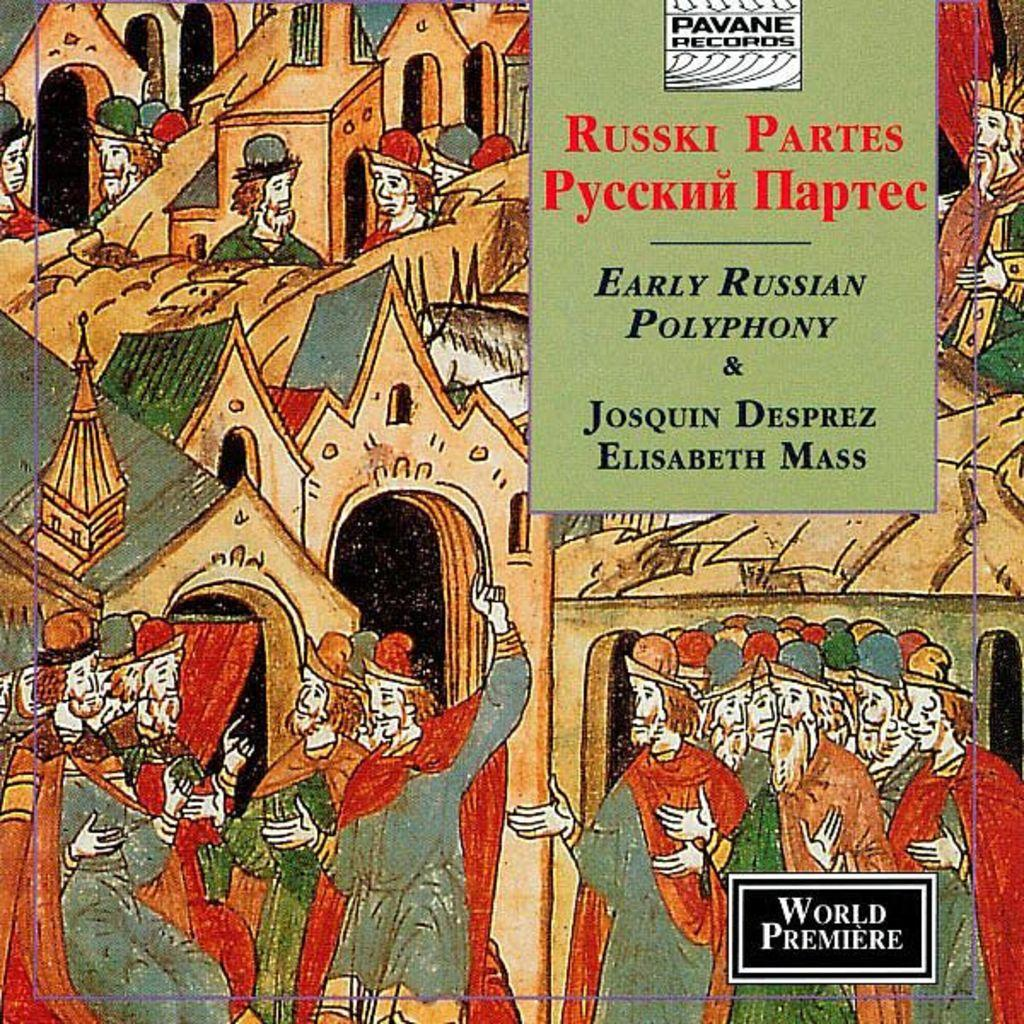<image>
Give a short and clear explanation of the subsequent image. A advertisement that says Russki Partes Early Russian Polyphony & Josquin Russian Elisabeth Mass. 